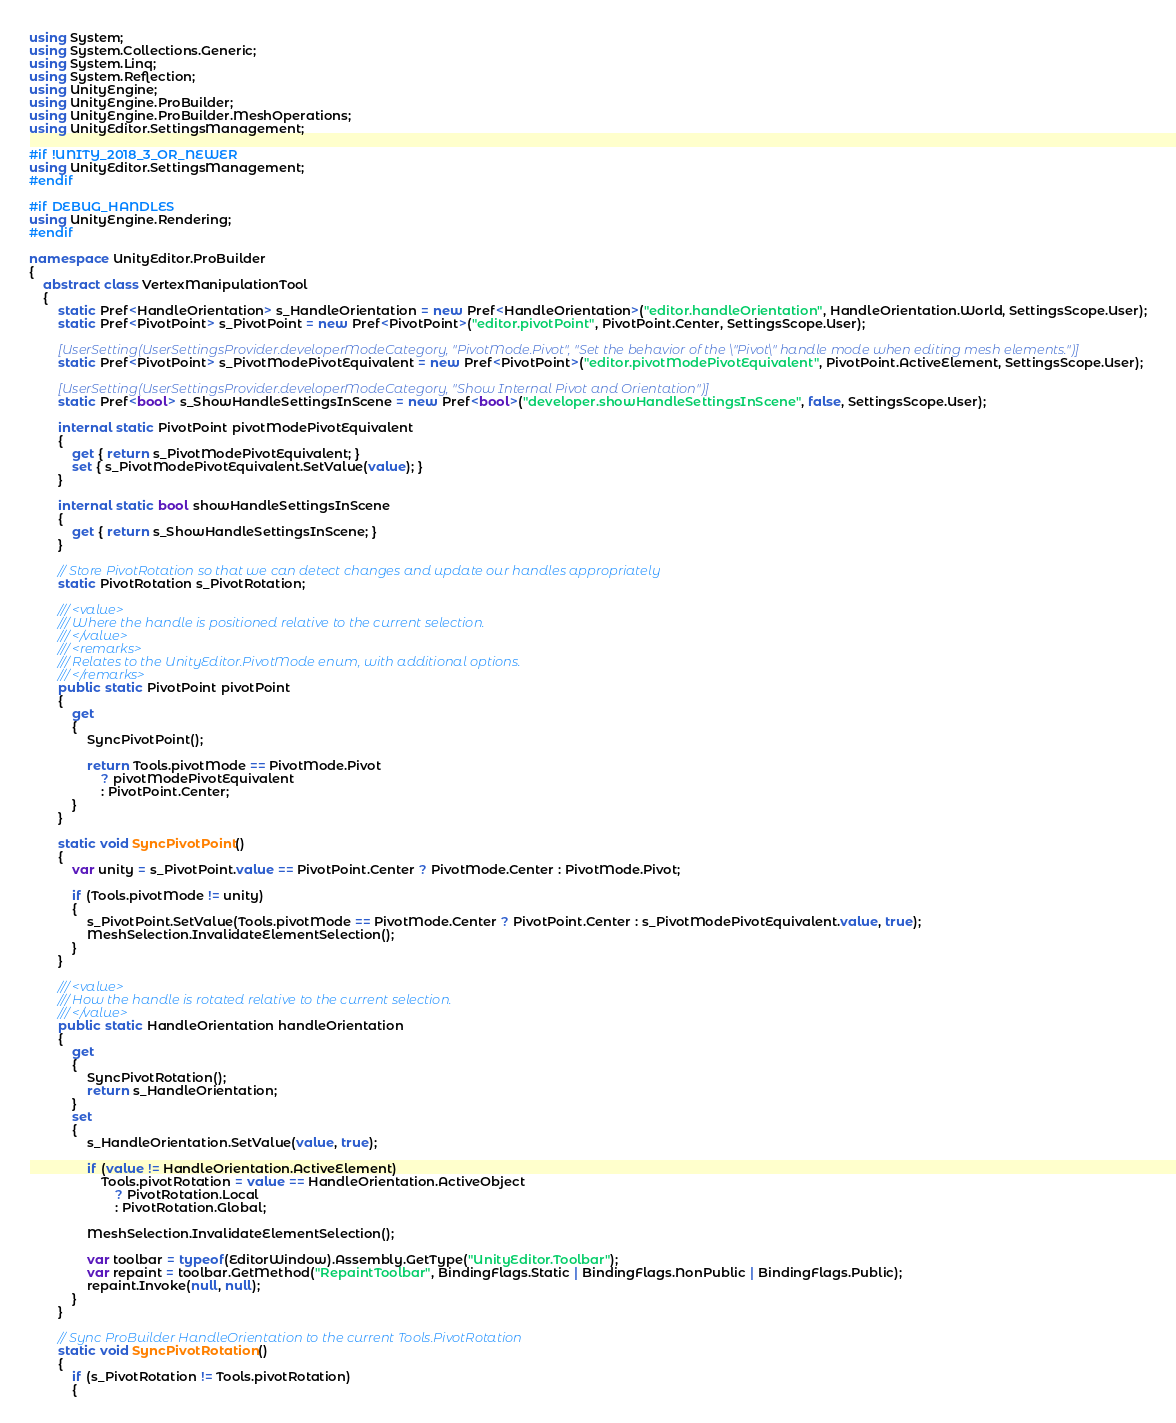Convert code to text. <code><loc_0><loc_0><loc_500><loc_500><_C#_>using System;
using System.Collections.Generic;
using System.Linq;
using System.Reflection;
using UnityEngine;
using UnityEngine.ProBuilder;
using UnityEngine.ProBuilder.MeshOperations;
using UnityEditor.SettingsManagement;

#if !UNITY_2018_3_OR_NEWER
using UnityEditor.SettingsManagement;
#endif

#if DEBUG_HANDLES
using UnityEngine.Rendering;
#endif

namespace UnityEditor.ProBuilder
{
    abstract class VertexManipulationTool
    {
        static Pref<HandleOrientation> s_HandleOrientation = new Pref<HandleOrientation>("editor.handleOrientation", HandleOrientation.World, SettingsScope.User);
        static Pref<PivotPoint> s_PivotPoint = new Pref<PivotPoint>("editor.pivotPoint", PivotPoint.Center, SettingsScope.User);

        [UserSetting(UserSettingsProvider.developerModeCategory, "PivotMode.Pivot", "Set the behavior of the \"Pivot\" handle mode when editing mesh elements.")]
        static Pref<PivotPoint> s_PivotModePivotEquivalent = new Pref<PivotPoint>("editor.pivotModePivotEquivalent", PivotPoint.ActiveElement, SettingsScope.User);

        [UserSetting(UserSettingsProvider.developerModeCategory, "Show Internal Pivot and Orientation")]
        static Pref<bool> s_ShowHandleSettingsInScene = new Pref<bool>("developer.showHandleSettingsInScene", false, SettingsScope.User);

        internal static PivotPoint pivotModePivotEquivalent
        {
            get { return s_PivotModePivotEquivalent; }
            set { s_PivotModePivotEquivalent.SetValue(value); }
        }

        internal static bool showHandleSettingsInScene
        {
            get { return s_ShowHandleSettingsInScene; }
        }

        // Store PivotRotation so that we can detect changes and update our handles appropriately
        static PivotRotation s_PivotRotation;

        /// <value>
        /// Where the handle is positioned relative to the current selection.
        /// </value>
        /// <remarks>
        /// Relates to the UnityEditor.PivotMode enum, with additional options.
        /// </remarks>
        public static PivotPoint pivotPoint
        {
            get
            {
                SyncPivotPoint();

                return Tools.pivotMode == PivotMode.Pivot
                    ? pivotModePivotEquivalent
                    : PivotPoint.Center;
            }
        }

        static void SyncPivotPoint()
        {
            var unity = s_PivotPoint.value == PivotPoint.Center ? PivotMode.Center : PivotMode.Pivot;

            if (Tools.pivotMode != unity)
            {
                s_PivotPoint.SetValue(Tools.pivotMode == PivotMode.Center ? PivotPoint.Center : s_PivotModePivotEquivalent.value, true);
                MeshSelection.InvalidateElementSelection();
            }
        }

        /// <value>
        /// How the handle is rotated relative to the current selection.
        /// </value>
        public static HandleOrientation handleOrientation
        {
            get
            {
                SyncPivotRotation();
                return s_HandleOrientation;
            }
            set
            {
                s_HandleOrientation.SetValue(value, true);

                if (value != HandleOrientation.ActiveElement)
                    Tools.pivotRotation = value == HandleOrientation.ActiveObject
                        ? PivotRotation.Local
                        : PivotRotation.Global;

                MeshSelection.InvalidateElementSelection();

                var toolbar = typeof(EditorWindow).Assembly.GetType("UnityEditor.Toolbar");
                var repaint = toolbar.GetMethod("RepaintToolbar", BindingFlags.Static | BindingFlags.NonPublic | BindingFlags.Public);
                repaint.Invoke(null, null);
            }
        }

        // Sync ProBuilder HandleOrientation to the current Tools.PivotRotation
        static void SyncPivotRotation()
        {
            if (s_PivotRotation != Tools.pivotRotation)
            {</code> 